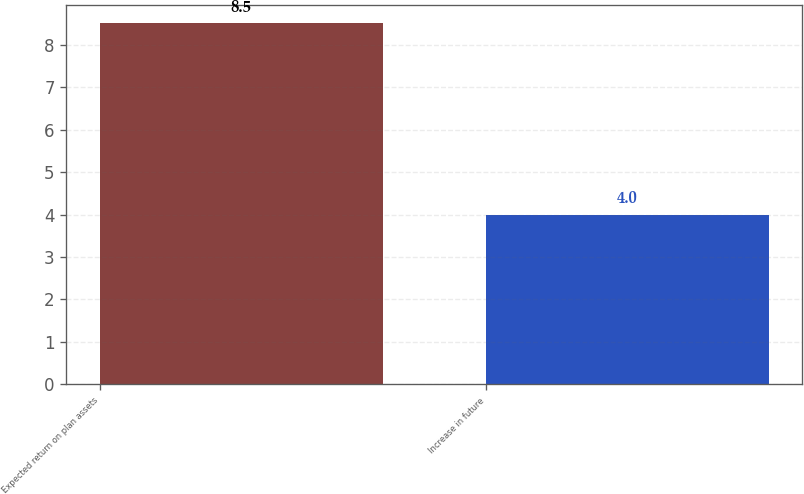Convert chart. <chart><loc_0><loc_0><loc_500><loc_500><bar_chart><fcel>Expected return on plan assets<fcel>Increase in future<nl><fcel>8.5<fcel>4<nl></chart> 